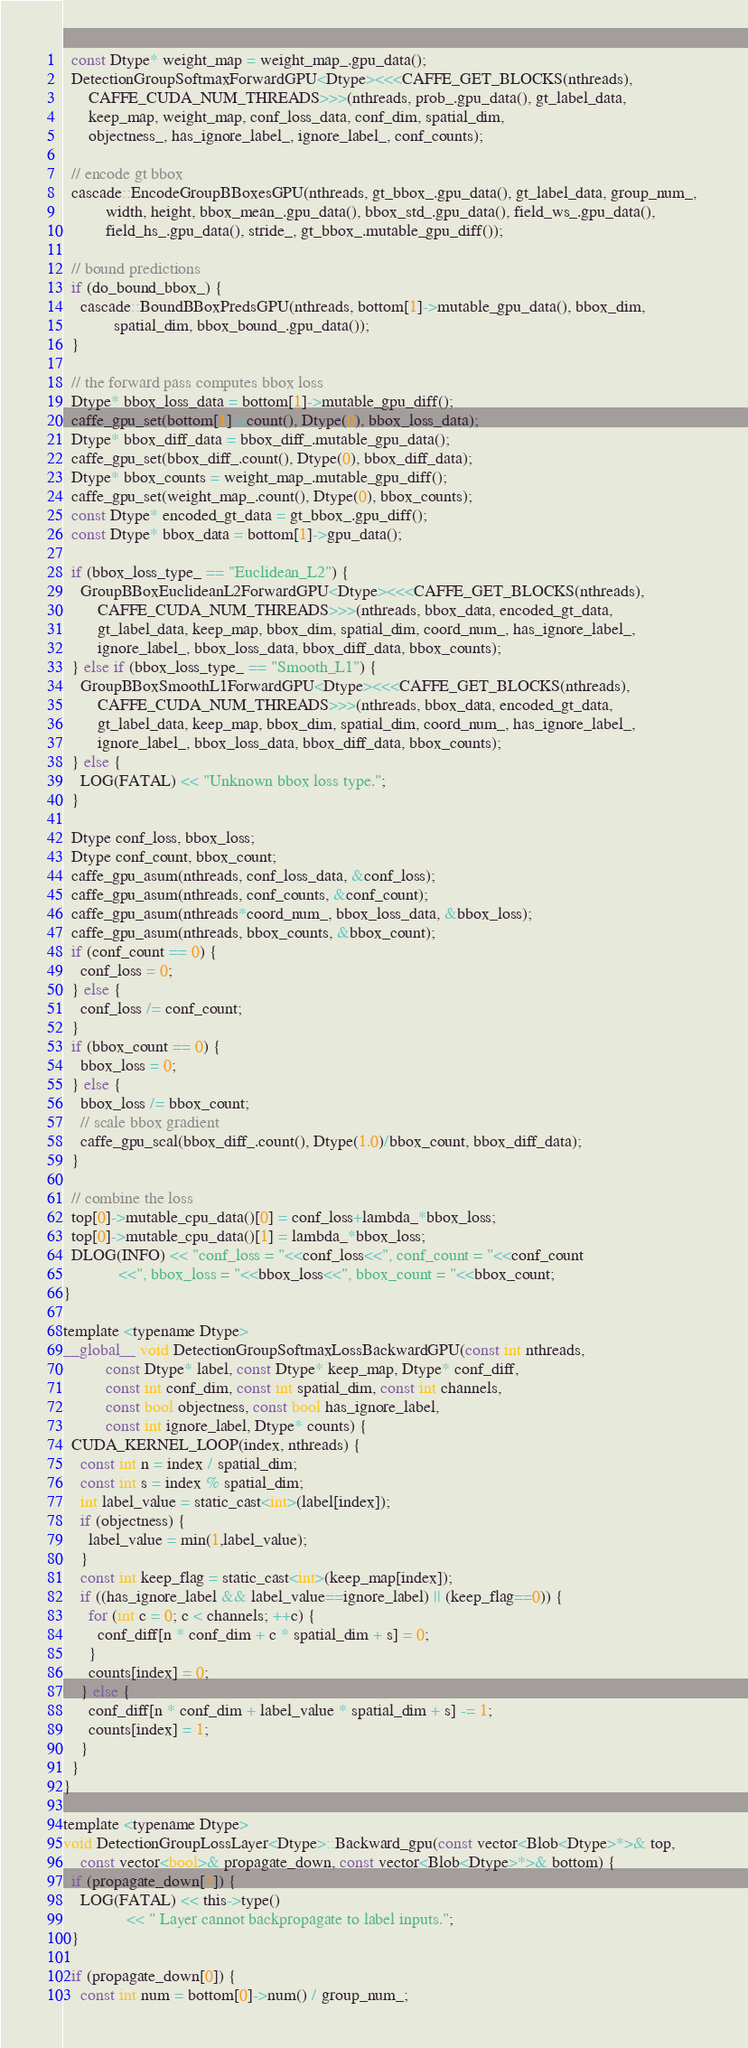Convert code to text. <code><loc_0><loc_0><loc_500><loc_500><_Cuda_>  const Dtype* weight_map = weight_map_.gpu_data();
  DetectionGroupSoftmaxForwardGPU<Dtype><<<CAFFE_GET_BLOCKS(nthreads),
      CAFFE_CUDA_NUM_THREADS>>>(nthreads, prob_.gpu_data(), gt_label_data, 
      keep_map, weight_map, conf_loss_data, conf_dim, spatial_dim, 
      objectness_, has_ignore_label_, ignore_label_, conf_counts);

  // encode gt bbox
  cascade::EncodeGroupBBoxesGPU(nthreads, gt_bbox_.gpu_data(), gt_label_data, group_num_, 
          width, height, bbox_mean_.gpu_data(), bbox_std_.gpu_data(), field_ws_.gpu_data(), 
          field_hs_.gpu_data(), stride_, gt_bbox_.mutable_gpu_diff());
  
  // bound predictions
  if (do_bound_bbox_) {
    cascade::BoundBBoxPredsGPU(nthreads, bottom[1]->mutable_gpu_data(), bbox_dim, 
            spatial_dim, bbox_bound_.gpu_data());
  }

  // the forward pass computes bbox loss 
  Dtype* bbox_loss_data = bottom[1]->mutable_gpu_diff();
  caffe_gpu_set(bottom[1]->count(), Dtype(0), bbox_loss_data);
  Dtype* bbox_diff_data = bbox_diff_.mutable_gpu_data();
  caffe_gpu_set(bbox_diff_.count(), Dtype(0), bbox_diff_data);
  Dtype* bbox_counts = weight_map_.mutable_gpu_diff();
  caffe_gpu_set(weight_map_.count(), Dtype(0), bbox_counts);
  const Dtype* encoded_gt_data = gt_bbox_.gpu_diff();
  const Dtype* bbox_data = bottom[1]->gpu_data();

  if (bbox_loss_type_ == "Euclidean_L2") {
    GroupBBoxEuclideanL2ForwardGPU<Dtype><<<CAFFE_GET_BLOCKS(nthreads),
        CAFFE_CUDA_NUM_THREADS>>>(nthreads, bbox_data, encoded_gt_data, 
        gt_label_data, keep_map, bbox_dim, spatial_dim, coord_num_, has_ignore_label_, 
        ignore_label_, bbox_loss_data, bbox_diff_data, bbox_counts);
  } else if (bbox_loss_type_ == "Smooth_L1") {
    GroupBBoxSmoothL1ForwardGPU<Dtype><<<CAFFE_GET_BLOCKS(nthreads),
        CAFFE_CUDA_NUM_THREADS>>>(nthreads, bbox_data, encoded_gt_data, 
        gt_label_data, keep_map, bbox_dim, spatial_dim, coord_num_, has_ignore_label_, 
        ignore_label_, bbox_loss_data, bbox_diff_data, bbox_counts);
  } else {
    LOG(FATAL) << "Unknown bbox loss type.";
  }

  Dtype conf_loss, bbox_loss;
  Dtype conf_count, bbox_count;
  caffe_gpu_asum(nthreads, conf_loss_data, &conf_loss);
  caffe_gpu_asum(nthreads, conf_counts, &conf_count); 
  caffe_gpu_asum(nthreads*coord_num_, bbox_loss_data, &bbox_loss);
  caffe_gpu_asum(nthreads, bbox_counts, &bbox_count);
  if (conf_count == 0) {
    conf_loss = 0;
  } else {
    conf_loss /= conf_count;
  }
  if (bbox_count == 0) {
    bbox_loss = 0;
  } else {
    bbox_loss /= bbox_count;
    // scale bbox gradient
    caffe_gpu_scal(bbox_diff_.count(), Dtype(1.0)/bbox_count, bbox_diff_data);
  }
  
  // combine the loss
  top[0]->mutable_cpu_data()[0] = conf_loss+lambda_*bbox_loss;
  top[0]->mutable_cpu_data()[1] = lambda_*bbox_loss;
  DLOG(INFO) << "conf_loss = "<<conf_loss<<", conf_count = "<<conf_count
             <<", bbox_loss = "<<bbox_loss<<", bbox_count = "<<bbox_count;
}

template <typename Dtype>
__global__ void DetectionGroupSoftmaxLossBackwardGPU(const int nthreads,
          const Dtype* label, const Dtype* keep_map, Dtype* conf_diff, 
          const int conf_dim, const int spatial_dim, const int channels, 
          const bool objectness, const bool has_ignore_label, 
          const int ignore_label, Dtype* counts) {
  CUDA_KERNEL_LOOP(index, nthreads) {
    const int n = index / spatial_dim;
    const int s = index % spatial_dim;
    int label_value = static_cast<int>(label[index]);
    if (objectness) {
      label_value = min(1,label_value);
    } 
    const int keep_flag = static_cast<int>(keep_map[index]);
    if ((has_ignore_label && label_value==ignore_label) || (keep_flag==0)) {
      for (int c = 0; c < channels; ++c) {
        conf_diff[n * conf_dim + c * spatial_dim + s] = 0;
      }
      counts[index] = 0;
    } else {
      conf_diff[n * conf_dim + label_value * spatial_dim + s] -= 1;
      counts[index] = 1;
    }
  }
}

template <typename Dtype>
void DetectionGroupLossLayer<Dtype>::Backward_gpu(const vector<Blob<Dtype>*>& top,
    const vector<bool>& propagate_down, const vector<Blob<Dtype>*>& bottom) {
  if (propagate_down[2]) {
    LOG(FATAL) << this->type()
               << " Layer cannot backpropagate to label inputs.";
  }

  if (propagate_down[0]) {
    const int num = bottom[0]->num() / group_num_;</code> 